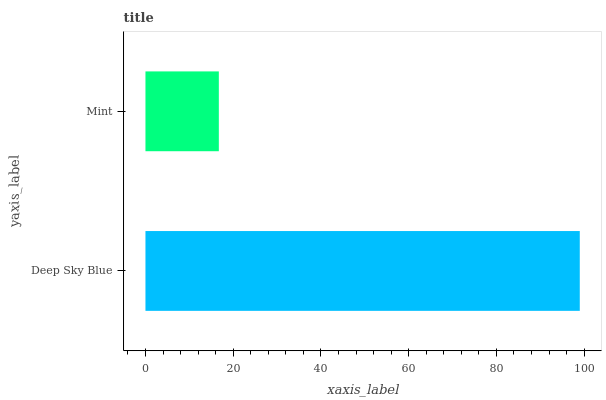Is Mint the minimum?
Answer yes or no. Yes. Is Deep Sky Blue the maximum?
Answer yes or no. Yes. Is Mint the maximum?
Answer yes or no. No. Is Deep Sky Blue greater than Mint?
Answer yes or no. Yes. Is Mint less than Deep Sky Blue?
Answer yes or no. Yes. Is Mint greater than Deep Sky Blue?
Answer yes or no. No. Is Deep Sky Blue less than Mint?
Answer yes or no. No. Is Deep Sky Blue the high median?
Answer yes or no. Yes. Is Mint the low median?
Answer yes or no. Yes. Is Mint the high median?
Answer yes or no. No. Is Deep Sky Blue the low median?
Answer yes or no. No. 